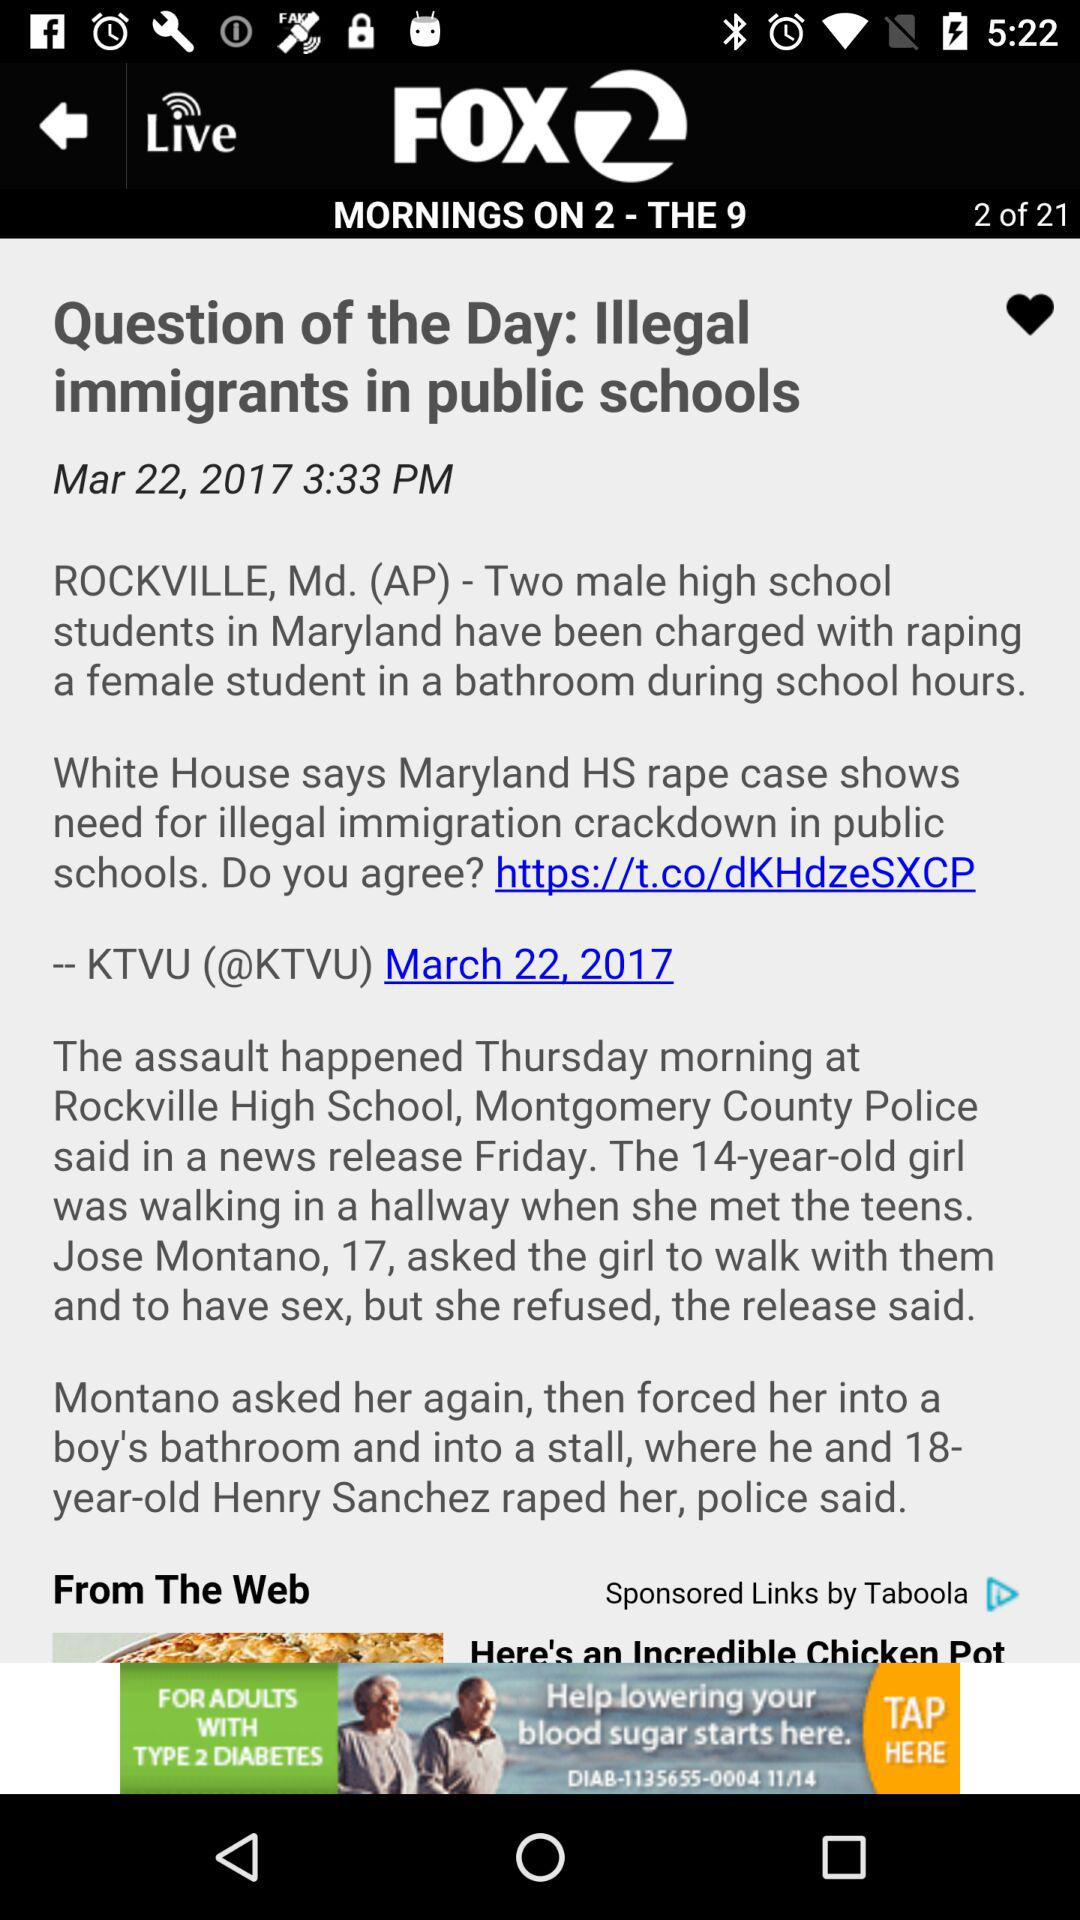What is the total number of pages? The total number of pages is 21. 